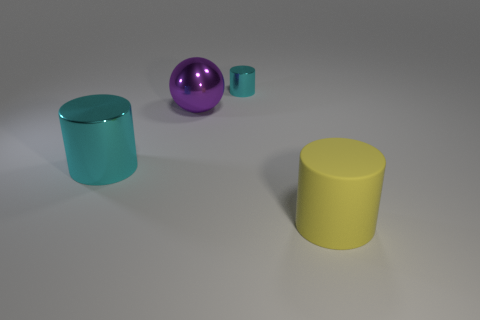Is the number of yellow rubber cylinders behind the large rubber thing less than the number of tiny blue cylinders?
Give a very brief answer. No. What is the color of the metal cylinder that is in front of the cyan shiny cylinder that is on the right side of the large cylinder behind the yellow cylinder?
Provide a short and direct response. Cyan. What number of shiny objects are either cylinders or cyan objects?
Your answer should be compact. 2. Is the purple metallic sphere the same size as the matte cylinder?
Offer a terse response. Yes. Are there fewer yellow cylinders on the left side of the purple metallic sphere than large yellow cylinders that are to the left of the big rubber cylinder?
Provide a succinct answer. No. Are there any other things that have the same size as the purple shiny object?
Offer a very short reply. Yes. The purple object is what size?
Your answer should be very brief. Large. How many large objects are either purple metallic objects or cyan objects?
Offer a terse response. 2. There is a metal sphere; does it have the same size as the cyan object in front of the small cyan shiny object?
Give a very brief answer. Yes. Is there any other thing that is the same shape as the large matte object?
Your response must be concise. Yes. 